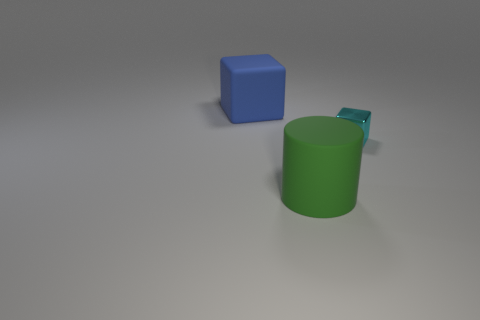Add 1 big rubber blocks. How many objects exist? 4 Subtract all blocks. How many objects are left? 1 Add 2 tiny gray rubber spheres. How many tiny gray rubber spheres exist? 2 Subtract 0 gray blocks. How many objects are left? 3 Subtract all small objects. Subtract all tiny yellow shiny balls. How many objects are left? 2 Add 2 small objects. How many small objects are left? 3 